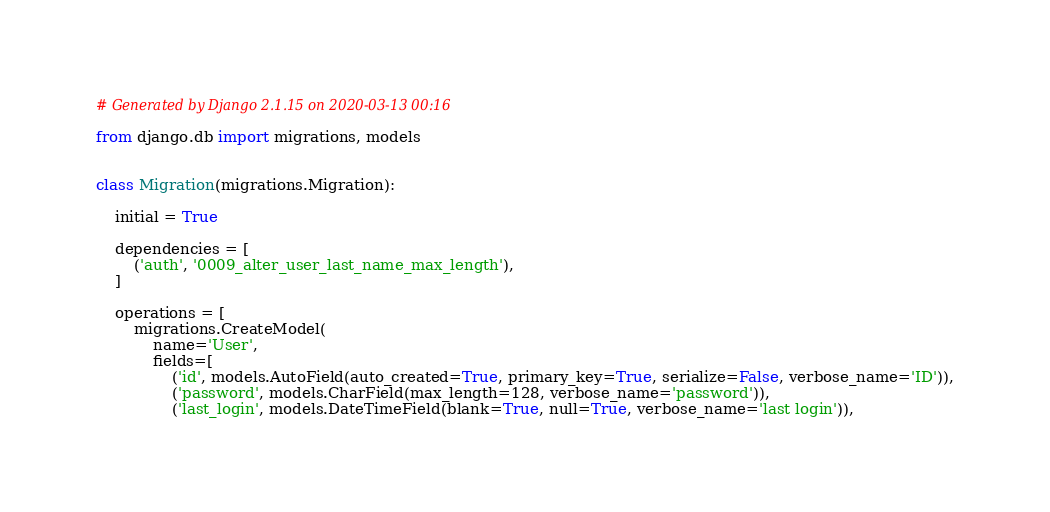Convert code to text. <code><loc_0><loc_0><loc_500><loc_500><_Python_># Generated by Django 2.1.15 on 2020-03-13 00:16

from django.db import migrations, models


class Migration(migrations.Migration):

    initial = True

    dependencies = [
        ('auth', '0009_alter_user_last_name_max_length'),
    ]

    operations = [
        migrations.CreateModel(
            name='User',
            fields=[
                ('id', models.AutoField(auto_created=True, primary_key=True, serialize=False, verbose_name='ID')),
                ('password', models.CharField(max_length=128, verbose_name='password')),
                ('last_login', models.DateTimeField(blank=True, null=True, verbose_name='last login')),</code> 